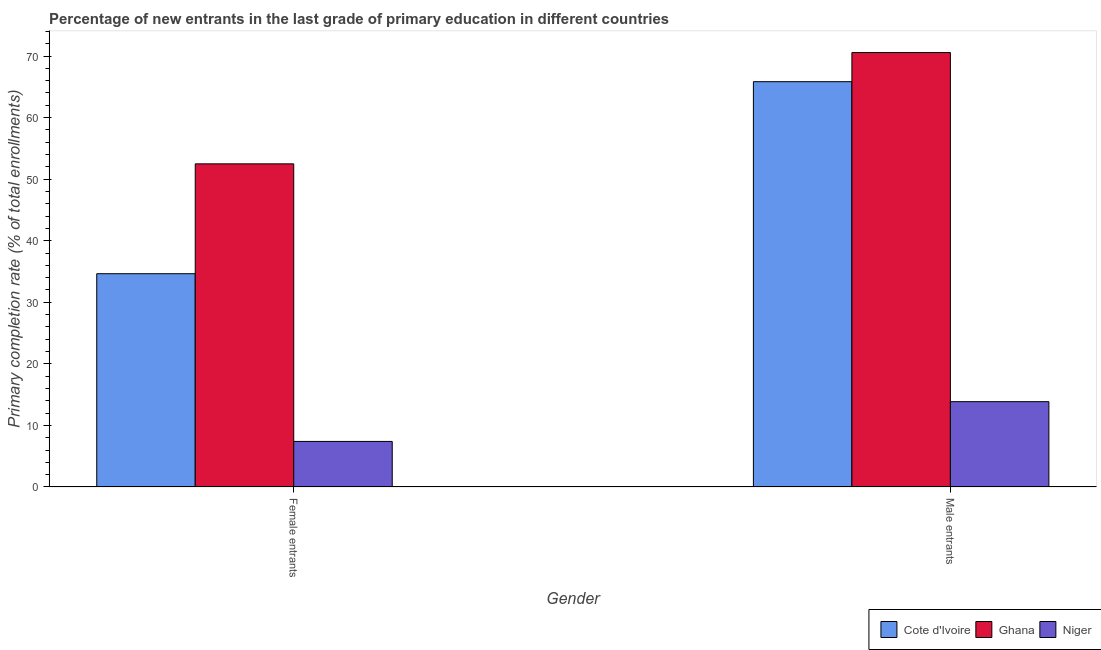Are the number of bars per tick equal to the number of legend labels?
Offer a very short reply. Yes. Are the number of bars on each tick of the X-axis equal?
Your response must be concise. Yes. How many bars are there on the 1st tick from the right?
Offer a terse response. 3. What is the label of the 1st group of bars from the left?
Your response must be concise. Female entrants. What is the primary completion rate of male entrants in Niger?
Your response must be concise. 13.86. Across all countries, what is the maximum primary completion rate of female entrants?
Your answer should be compact. 52.49. Across all countries, what is the minimum primary completion rate of male entrants?
Provide a short and direct response. 13.86. In which country was the primary completion rate of male entrants maximum?
Your answer should be compact. Ghana. In which country was the primary completion rate of female entrants minimum?
Offer a terse response. Niger. What is the total primary completion rate of male entrants in the graph?
Offer a very short reply. 150.26. What is the difference between the primary completion rate of female entrants in Niger and that in Cote d'Ivoire?
Give a very brief answer. -27.24. What is the difference between the primary completion rate of male entrants in Cote d'Ivoire and the primary completion rate of female entrants in Niger?
Make the answer very short. 58.43. What is the average primary completion rate of male entrants per country?
Make the answer very short. 50.09. What is the difference between the primary completion rate of male entrants and primary completion rate of female entrants in Cote d'Ivoire?
Offer a terse response. 31.19. What is the ratio of the primary completion rate of male entrants in Niger to that in Ghana?
Give a very brief answer. 0.2. Is the primary completion rate of female entrants in Ghana less than that in Cote d'Ivoire?
Provide a succinct answer. No. In how many countries, is the primary completion rate of male entrants greater than the average primary completion rate of male entrants taken over all countries?
Ensure brevity in your answer.  2. What does the 1st bar from the left in Male entrants represents?
Your response must be concise. Cote d'Ivoire. What does the 3rd bar from the right in Female entrants represents?
Provide a succinct answer. Cote d'Ivoire. How many bars are there?
Provide a succinct answer. 6. How many countries are there in the graph?
Offer a very short reply. 3. What is the difference between two consecutive major ticks on the Y-axis?
Make the answer very short. 10. Are the values on the major ticks of Y-axis written in scientific E-notation?
Ensure brevity in your answer.  No. Does the graph contain any zero values?
Ensure brevity in your answer.  No. Where does the legend appear in the graph?
Offer a terse response. Bottom right. How many legend labels are there?
Provide a short and direct response. 3. What is the title of the graph?
Give a very brief answer. Percentage of new entrants in the last grade of primary education in different countries. Does "Namibia" appear as one of the legend labels in the graph?
Offer a very short reply. No. What is the label or title of the X-axis?
Your response must be concise. Gender. What is the label or title of the Y-axis?
Your answer should be very brief. Primary completion rate (% of total enrollments). What is the Primary completion rate (% of total enrollments) in Cote d'Ivoire in Female entrants?
Your answer should be compact. 34.64. What is the Primary completion rate (% of total enrollments) in Ghana in Female entrants?
Provide a succinct answer. 52.49. What is the Primary completion rate (% of total enrollments) in Niger in Female entrants?
Make the answer very short. 7.4. What is the Primary completion rate (% of total enrollments) in Cote d'Ivoire in Male entrants?
Ensure brevity in your answer.  65.83. What is the Primary completion rate (% of total enrollments) in Ghana in Male entrants?
Provide a short and direct response. 70.56. What is the Primary completion rate (% of total enrollments) in Niger in Male entrants?
Give a very brief answer. 13.86. Across all Gender, what is the maximum Primary completion rate (% of total enrollments) of Cote d'Ivoire?
Make the answer very short. 65.83. Across all Gender, what is the maximum Primary completion rate (% of total enrollments) in Ghana?
Give a very brief answer. 70.56. Across all Gender, what is the maximum Primary completion rate (% of total enrollments) of Niger?
Provide a succinct answer. 13.86. Across all Gender, what is the minimum Primary completion rate (% of total enrollments) in Cote d'Ivoire?
Make the answer very short. 34.64. Across all Gender, what is the minimum Primary completion rate (% of total enrollments) of Ghana?
Ensure brevity in your answer.  52.49. Across all Gender, what is the minimum Primary completion rate (% of total enrollments) in Niger?
Your answer should be very brief. 7.4. What is the total Primary completion rate (% of total enrollments) of Cote d'Ivoire in the graph?
Offer a very short reply. 100.48. What is the total Primary completion rate (% of total enrollments) of Ghana in the graph?
Provide a succinct answer. 123.05. What is the total Primary completion rate (% of total enrollments) in Niger in the graph?
Offer a terse response. 21.26. What is the difference between the Primary completion rate (% of total enrollments) of Cote d'Ivoire in Female entrants and that in Male entrants?
Provide a succinct answer. -31.19. What is the difference between the Primary completion rate (% of total enrollments) in Ghana in Female entrants and that in Male entrants?
Offer a very short reply. -18.08. What is the difference between the Primary completion rate (% of total enrollments) of Niger in Female entrants and that in Male entrants?
Offer a terse response. -6.46. What is the difference between the Primary completion rate (% of total enrollments) in Cote d'Ivoire in Female entrants and the Primary completion rate (% of total enrollments) in Ghana in Male entrants?
Your response must be concise. -35.92. What is the difference between the Primary completion rate (% of total enrollments) of Cote d'Ivoire in Female entrants and the Primary completion rate (% of total enrollments) of Niger in Male entrants?
Ensure brevity in your answer.  20.78. What is the difference between the Primary completion rate (% of total enrollments) of Ghana in Female entrants and the Primary completion rate (% of total enrollments) of Niger in Male entrants?
Provide a short and direct response. 38.63. What is the average Primary completion rate (% of total enrollments) of Cote d'Ivoire per Gender?
Keep it short and to the point. 50.24. What is the average Primary completion rate (% of total enrollments) of Ghana per Gender?
Your answer should be compact. 61.53. What is the average Primary completion rate (% of total enrollments) in Niger per Gender?
Provide a succinct answer. 10.63. What is the difference between the Primary completion rate (% of total enrollments) in Cote d'Ivoire and Primary completion rate (% of total enrollments) in Ghana in Female entrants?
Your answer should be compact. -17.84. What is the difference between the Primary completion rate (% of total enrollments) of Cote d'Ivoire and Primary completion rate (% of total enrollments) of Niger in Female entrants?
Keep it short and to the point. 27.24. What is the difference between the Primary completion rate (% of total enrollments) of Ghana and Primary completion rate (% of total enrollments) of Niger in Female entrants?
Make the answer very short. 45.09. What is the difference between the Primary completion rate (% of total enrollments) in Cote d'Ivoire and Primary completion rate (% of total enrollments) in Ghana in Male entrants?
Provide a short and direct response. -4.73. What is the difference between the Primary completion rate (% of total enrollments) of Cote d'Ivoire and Primary completion rate (% of total enrollments) of Niger in Male entrants?
Provide a succinct answer. 51.97. What is the difference between the Primary completion rate (% of total enrollments) in Ghana and Primary completion rate (% of total enrollments) in Niger in Male entrants?
Make the answer very short. 56.71. What is the ratio of the Primary completion rate (% of total enrollments) of Cote d'Ivoire in Female entrants to that in Male entrants?
Ensure brevity in your answer.  0.53. What is the ratio of the Primary completion rate (% of total enrollments) in Ghana in Female entrants to that in Male entrants?
Ensure brevity in your answer.  0.74. What is the ratio of the Primary completion rate (% of total enrollments) of Niger in Female entrants to that in Male entrants?
Your response must be concise. 0.53. What is the difference between the highest and the second highest Primary completion rate (% of total enrollments) of Cote d'Ivoire?
Keep it short and to the point. 31.19. What is the difference between the highest and the second highest Primary completion rate (% of total enrollments) in Ghana?
Make the answer very short. 18.08. What is the difference between the highest and the second highest Primary completion rate (% of total enrollments) of Niger?
Your response must be concise. 6.46. What is the difference between the highest and the lowest Primary completion rate (% of total enrollments) in Cote d'Ivoire?
Your response must be concise. 31.19. What is the difference between the highest and the lowest Primary completion rate (% of total enrollments) of Ghana?
Your response must be concise. 18.08. What is the difference between the highest and the lowest Primary completion rate (% of total enrollments) in Niger?
Your response must be concise. 6.46. 